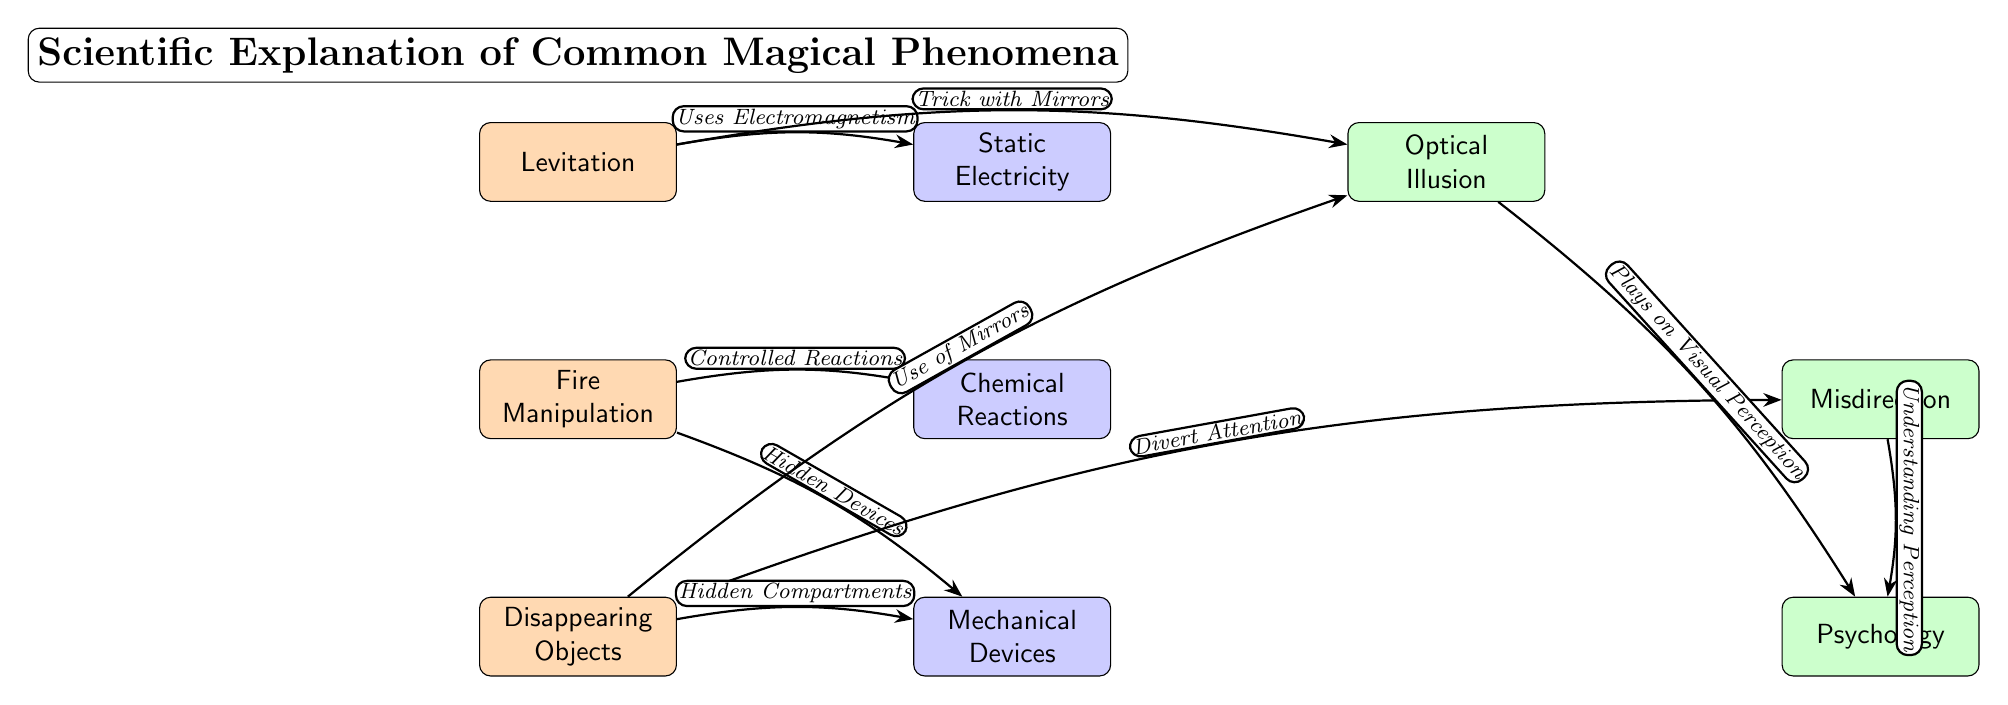What phenomenon is on the top of the diagram? The diagram lists "Levitation" at the top as the first phenomenon.
Answer: Levitation How many phenomena are depicted in the diagram? The diagram has three phenomena: Levitation, Fire Manipulation, and Disappearing Objects. This can be counted by noting the phenomenon nodes.
Answer: 3 What explanation is associated with Fire Manipulation? The diagram connects "Chemical Reactions" as the explanation for Fire Manipulation. This is found by looking for the node labeled "Fire Manipulation" and tracing the connection.
Answer: Chemical Reactions Which principle connects to optical illusion? The diagram shows that "Psychology" is connected to "Optical Illusion," indicating a relationship between the two. This can be seen by following the edge from the optical illusion node.
Answer: Psychology What is the relationship between Levitation and Static Electricity? The edge labeled "Uses Electromagnetism" indicates that Levitation uses Static Electricity as part of its explanation. The wording on the edge describes the specific relationship.
Answer: Uses Electromagnetism How does disappearing objects relate to misdirection? The diagram states that disappearing objects involve "Divert Attention," which is associated with "Misdirection" indicating that this principle plays a significant role in the illusion.
Answer: Divert Attention Which phenomena are explained through mechanical devices? "Disappearing Objects" and "Fire Manipulation" are both explained through the use of "Mechanical Devices," as shown by the edges leading from these phenomena to the shared explanation node.
Answer: Disappearing Objects, Fire Manipulation Which principle is associated with understanding perception? The diagram indicates that "Misdirection" connects to "Psychology" through an edge labeled "Understanding Perception," highlighting how psychology plays a role in the art of misdirection.
Answer: Understanding Perception What connects fire manipulation to controlled reactions? The edge labeled "Controlled Reactions" links Fire Manipulation to its explanation, showing a direct cause-and-effect relationship in the diagram's structure regarding fire.
Answer: Controlled Reactions 